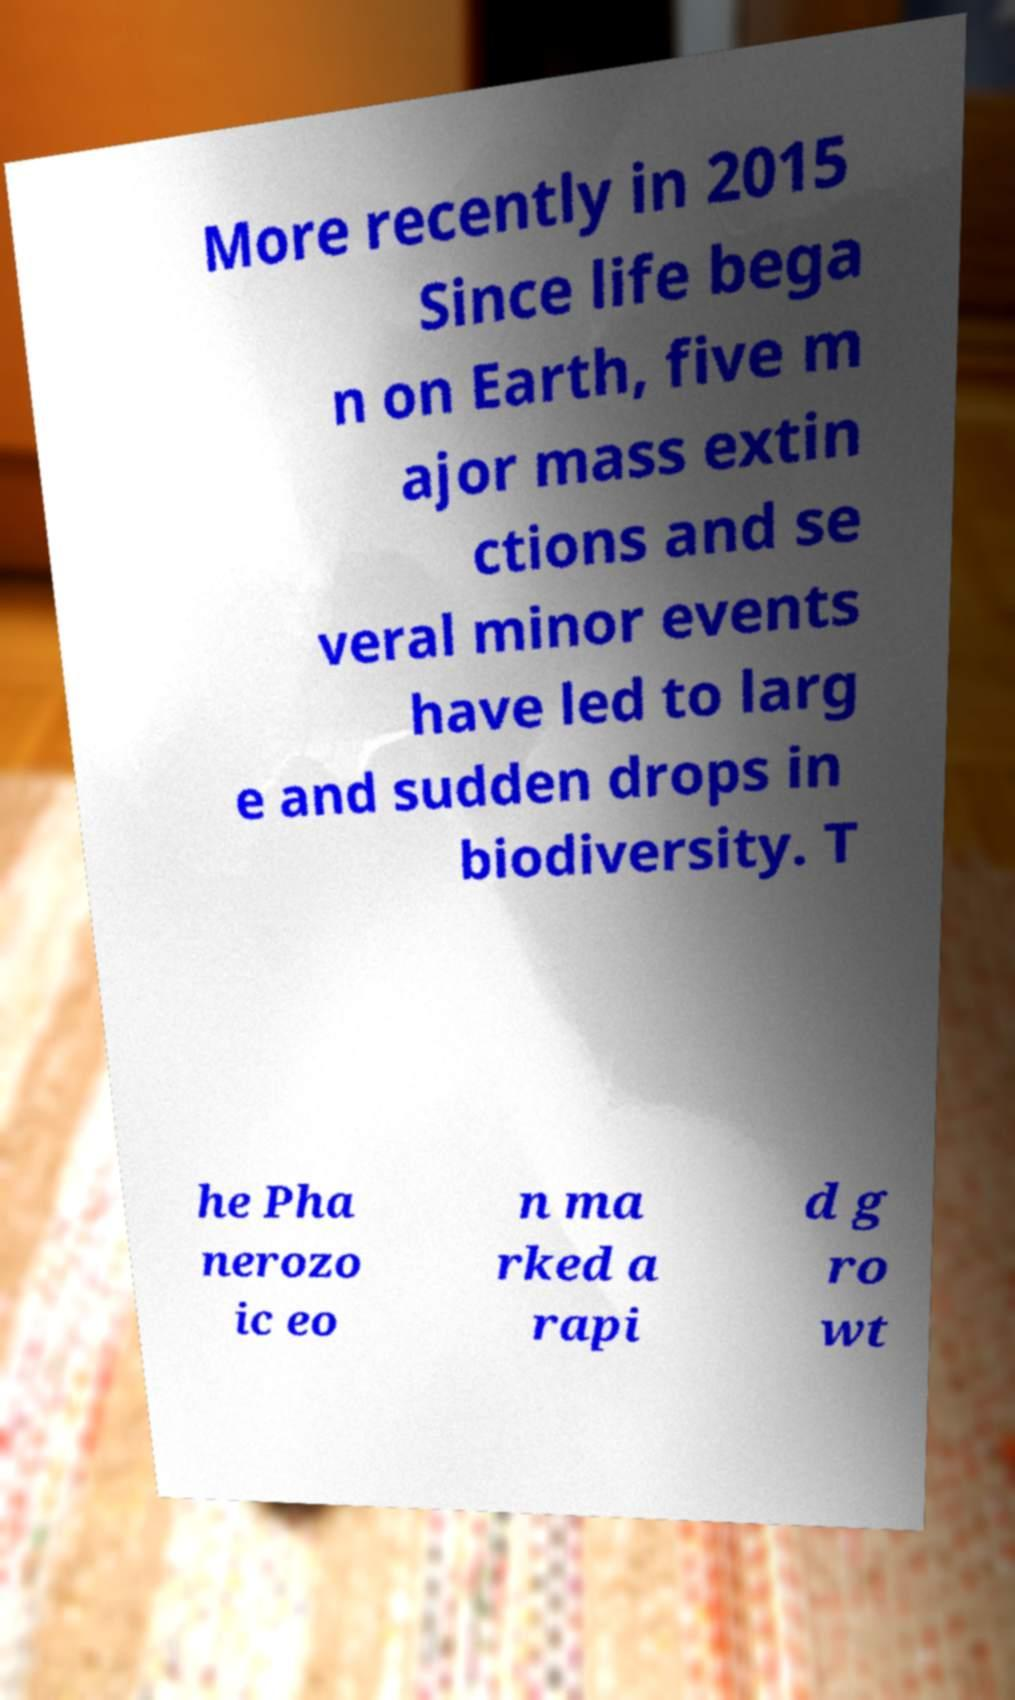There's text embedded in this image that I need extracted. Can you transcribe it verbatim? More recently in 2015 Since life bega n on Earth, five m ajor mass extin ctions and se veral minor events have led to larg e and sudden drops in biodiversity. T he Pha nerozo ic eo n ma rked a rapi d g ro wt 